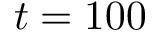<formula> <loc_0><loc_0><loc_500><loc_500>t = 1 0 0</formula> 